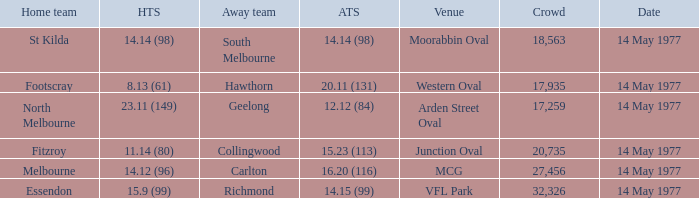How many people were in the crowd with the away team being collingwood? 1.0. 